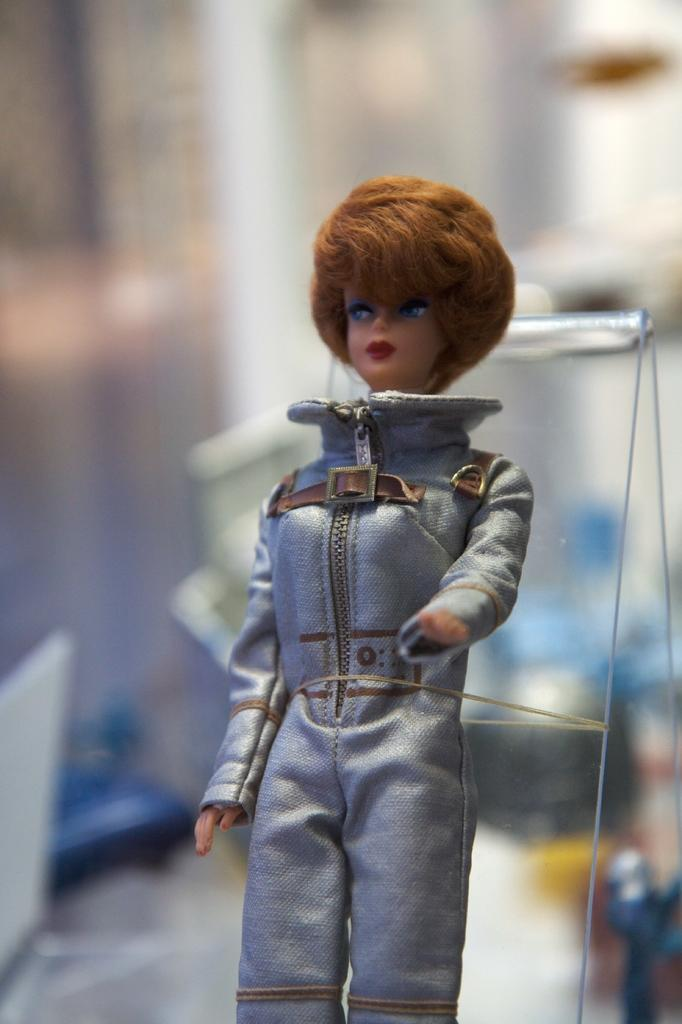What is the main subject of the image? There is a doll in the image. How is the doll connected to another object in the image? The doll is tied to a glass object. What can be observed about the background of the doll? The background of the doll is blurred. What type of attraction can be seen in the background of the image? There is no attraction visible in the background of the image; the background is blurred. How many cows are present in the image? There are no cows present in the image; it features a doll tied to a glass object with a blurred background. 